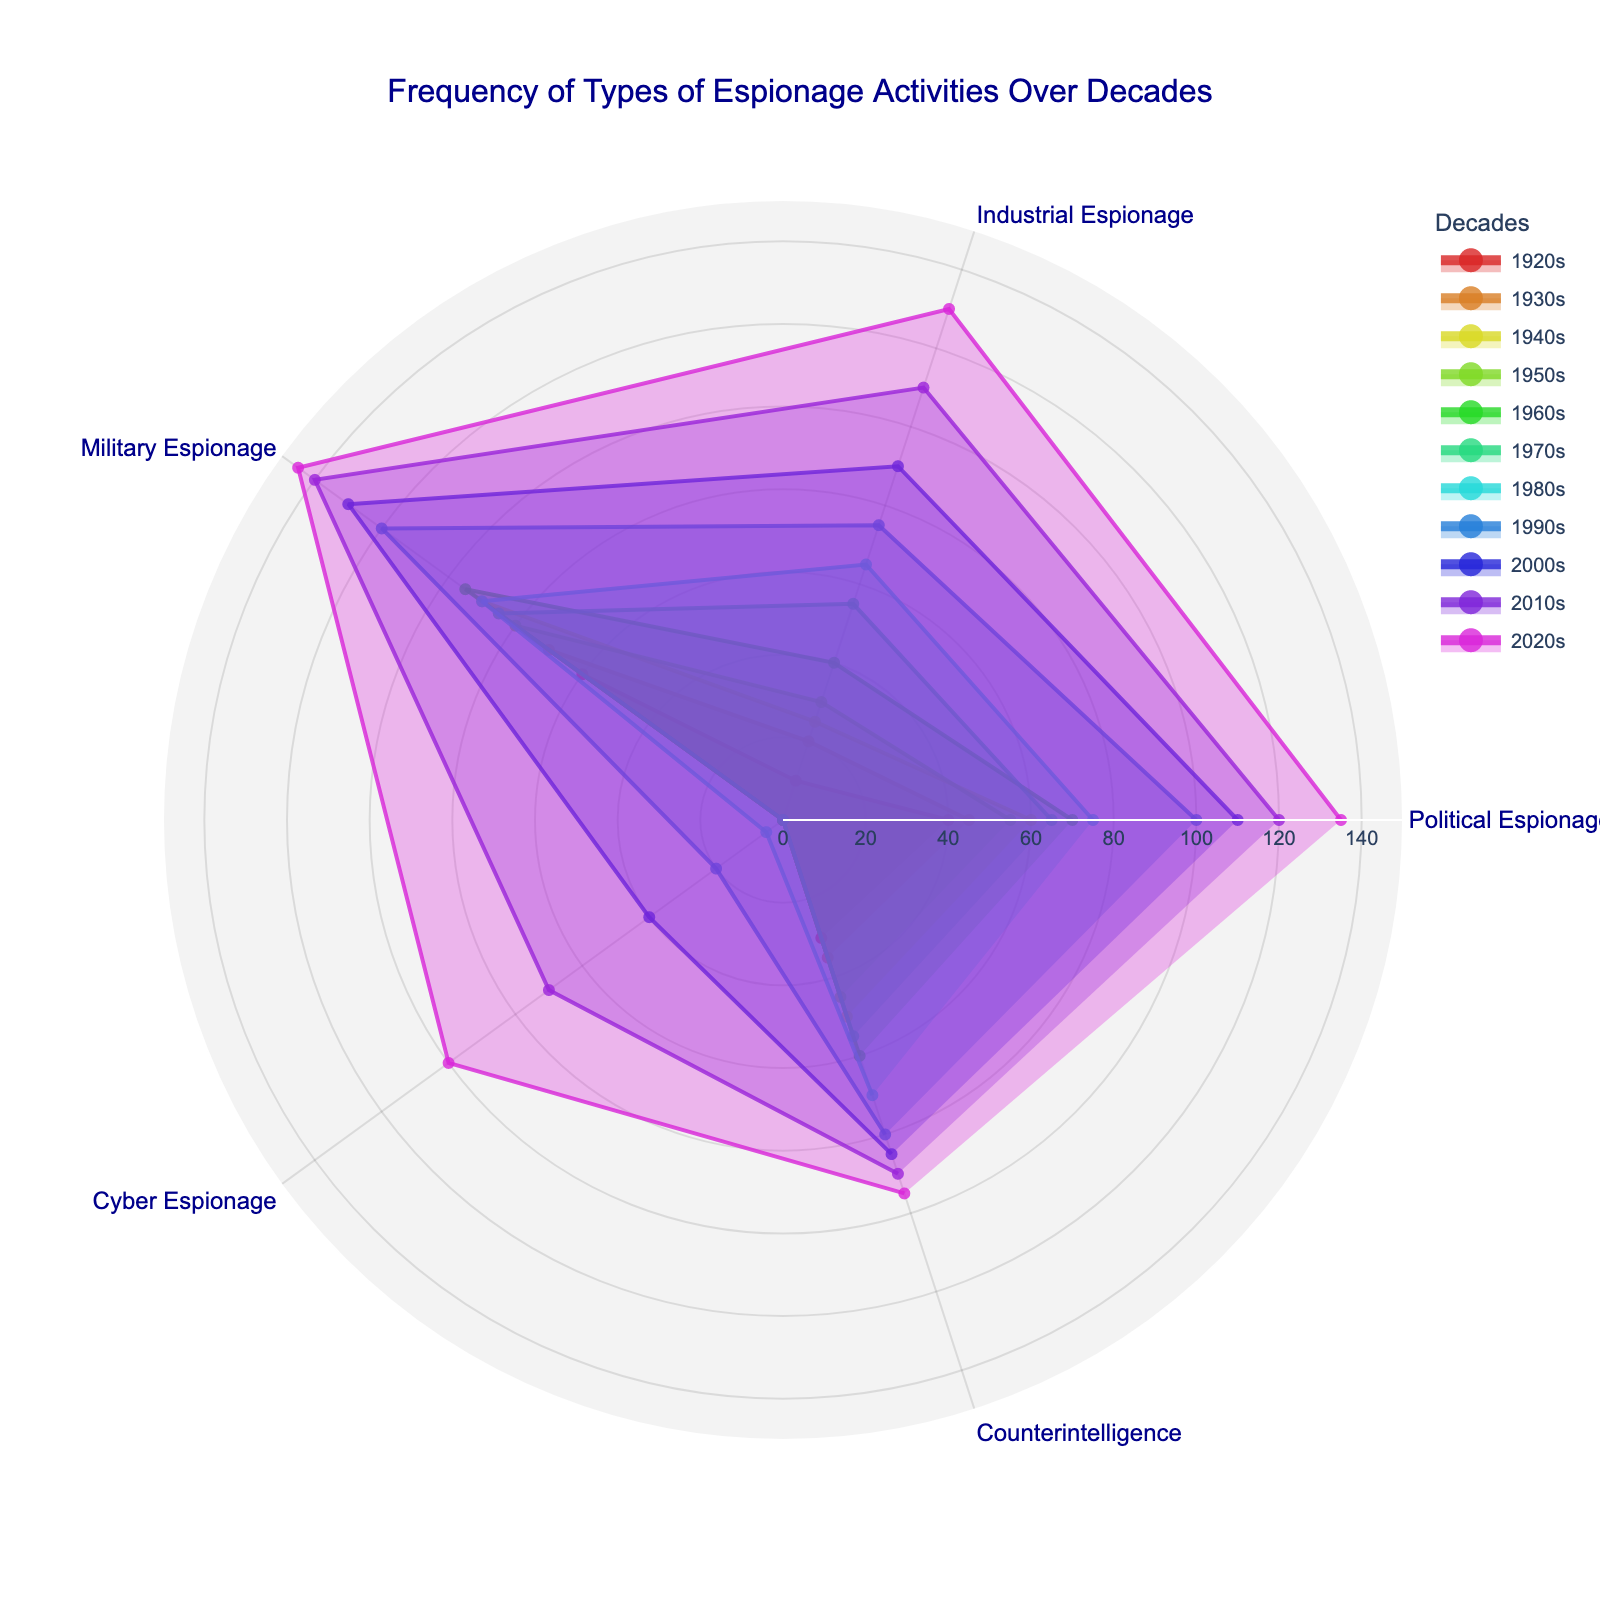what's the title of the figure? The title of the figure is displayed at the top of the chart, and it provides an overall description of what the figure represents. In this case, it is "Frequency of Types of Espionage Activities Over Decades".
Answer: Frequency of Types of Espionage Activities Over Decades Which decade shows the highest frequency of Industrial Espionage? By examining the figure, we need to find the highest value along the "Industrial Espionage" axis. The 2020s show the highest value with a frequency of 130.
Answer: 2020s What is the difference in frequency of Military Espionage between the 1940s and 1960s? To find the difference, identify the values for "Military Espionage" in both decades and subtract one from the other: 95 (1960s) - 90 (1940s) = 5.
Answer: 5 In which decade did Cyber Espionage begin to appear? By looking for the first decade with a non-zero value on the "Cyber Espionage" axis, we see that Cyber Espionage began in the 1980s.
Answer: 1980s How does the frequency of Political Espionage in the 1920s compare to that in the 2020s? Compare the values on the "Political Espionage" axis for both decades: 40 (1920s) and 135 (2020s). The frequency in the 2020s is greater.
Answer: greater What are the frequencies of Counterintelligence in the 1930s and 2010s? Locate the values on the "Counterintelligence" axis for both decades. In the 1930s, it is 35, and in the 2010s, it is 90.
Answer: 35 and 90 Which category of espionage shows a significant increase in the 2000s compared to the previous decades? By comparing the data of different categories across decades, "Cyber Espionage" shows a significant increase in the 2000s, jumping from 5 in the 1980s to 40 in the 2000s.
Answer: Cyber Espionage What is the average frequency of Industrial Espionage in the 1950s and 1980s? Add the frequencies from both decades and divide by 2: (30 + 65) / 2 = 95 / 2 = 47.5.
Answer: 47.5 Which category had consistent frequency increases every decade from the 1920s to the 2020s? By examining the figure, "Political Espionage" shows consistent increases across all decades.
Answer: Political Espionage What's the total frequency of all types of espionage in the 1990s? Add the values of all espionage categories for the 1990s: 100 + 75 + 120 + 20 + 80 = 395.
Answer: 395 